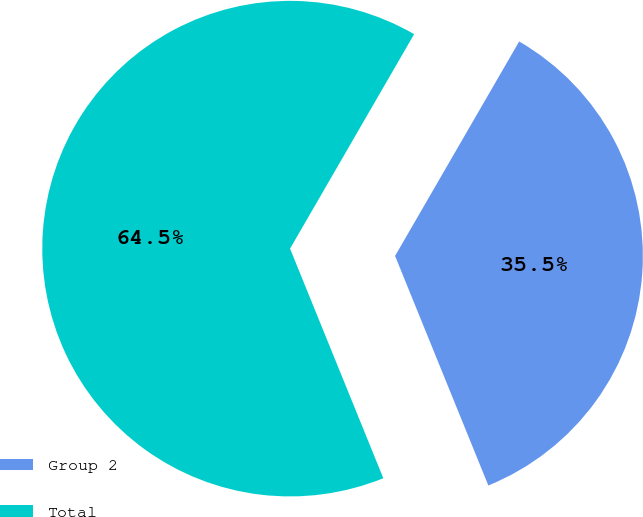Convert chart. <chart><loc_0><loc_0><loc_500><loc_500><pie_chart><fcel>Group 2<fcel>Total<nl><fcel>35.51%<fcel>64.49%<nl></chart> 